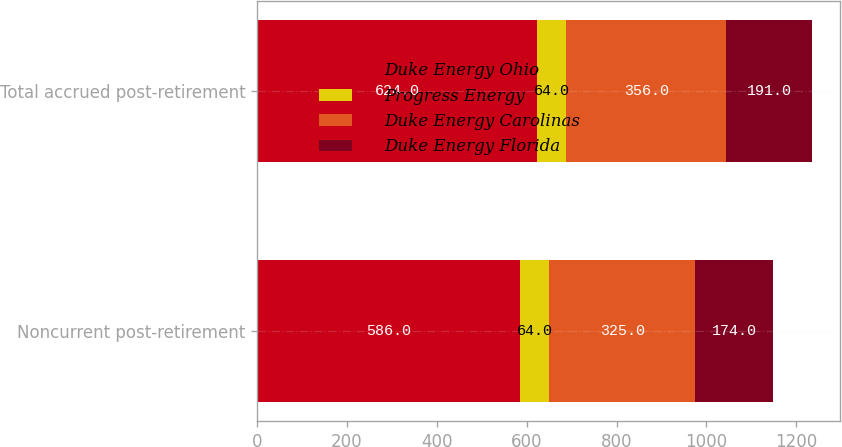<chart> <loc_0><loc_0><loc_500><loc_500><stacked_bar_chart><ecel><fcel>Noncurrent post-retirement<fcel>Total accrued post-retirement<nl><fcel>Duke Energy Ohio<fcel>586<fcel>624<nl><fcel>Progress Energy<fcel>64<fcel>64<nl><fcel>Duke Energy Carolinas<fcel>325<fcel>356<nl><fcel>Duke Energy Florida<fcel>174<fcel>191<nl></chart> 